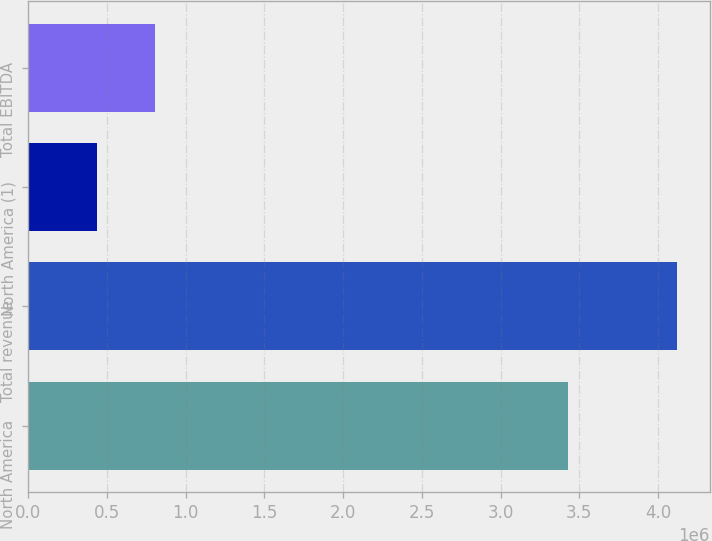<chart> <loc_0><loc_0><loc_500><loc_500><bar_chart><fcel>North America<fcel>Total revenue<fcel>North America (1)<fcel>Total EBITDA<nl><fcel>3.42686e+06<fcel>4.12293e+06<fcel>440448<fcel>808696<nl></chart> 